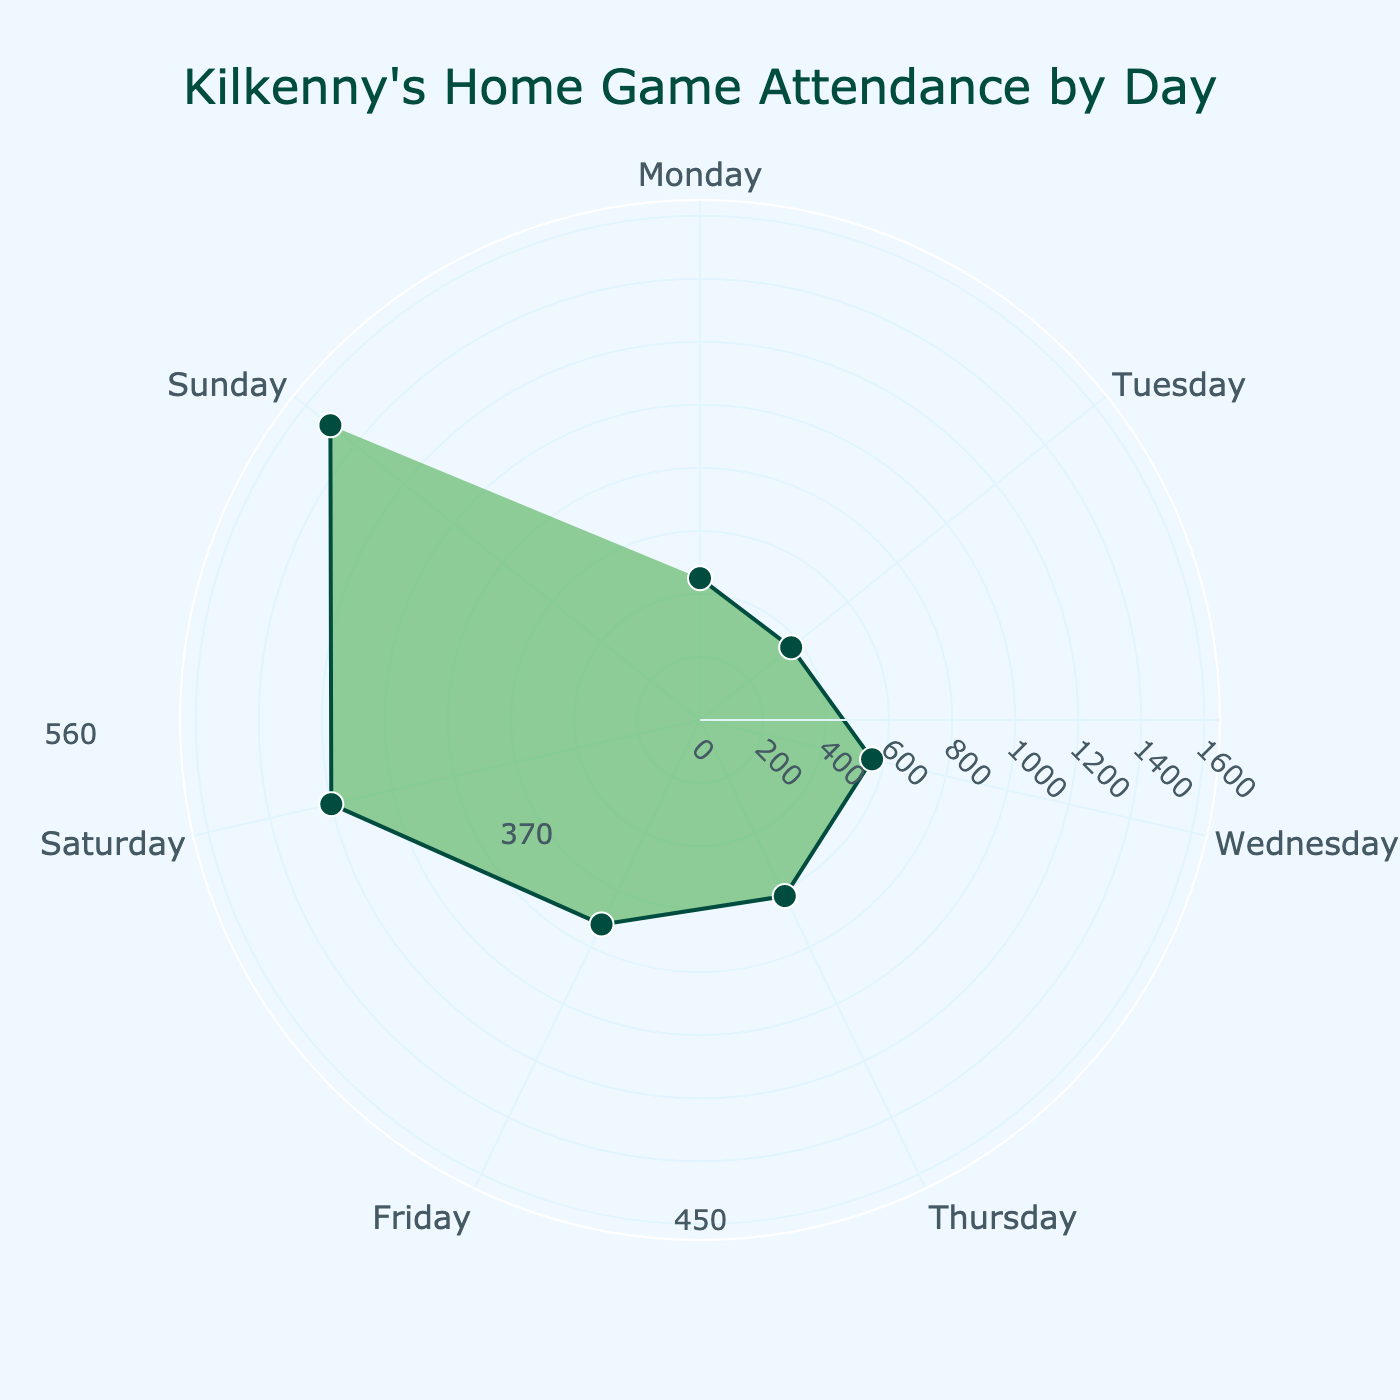What is the title of the polar chart? The title of a figure is typically placed at the top and it gives an overview of what the chart is about. In this case, it is written at the top center of the chart with larger and darker text.
Answer: Kilkenny's Home Game Attendance by Day Which day of the week has the highest attendance? You can see this by looking at the polar chart and finding the day with the longest radial distance from the center. This day is labeled at the edge of the chart.
Answer: Sunday How many days have attendances greater than 1000? To answer this, look at each day's attendance on the chart and count how many times the attendance value is greater than 1000.
Answer: 2 What's the average attendance from Monday to Thursday? Sum the attendance values for Monday, Tuesday, Wednesday, and Thursday and then divide by the number of days (4). The values are 450, 370, 560, and 620 respectively. Calculation: (450 + 370 + 560 + 620) / 4 = 2000 / 4 = 500.
Answer: 500 Which two consecutive days show the biggest increase in attendance? Identify the days using their attendance values, then note the pair of consecutive days with the largest difference in values. Consecutive days here means one day after the other in the week.
Answer: Friday to Saturday Does Saturday have higher attendance than any weekday? Compare Saturday's attendance with those of Monday, Tuesday, Wednesday, Thursday, and Friday.
Answer: Yes How much more is the attendance on the busiest day compared to the least busy day? Find the attendance for the busiest day (Sunday) and the least busy day (Tuesday). Subtract the least busy day's attendance from the busiest day's attendance: 1500 - 370.
Answer: 1130 What is the median attendance for Kilkenny's home games based on the days provided? To find the median, list the attendances in ascending order and find the middle value. The ordered values are 370, 450, 560, 620, 720, 1200, 1500. The middle value is the fourth one in the ordered list.
Answer: 620 